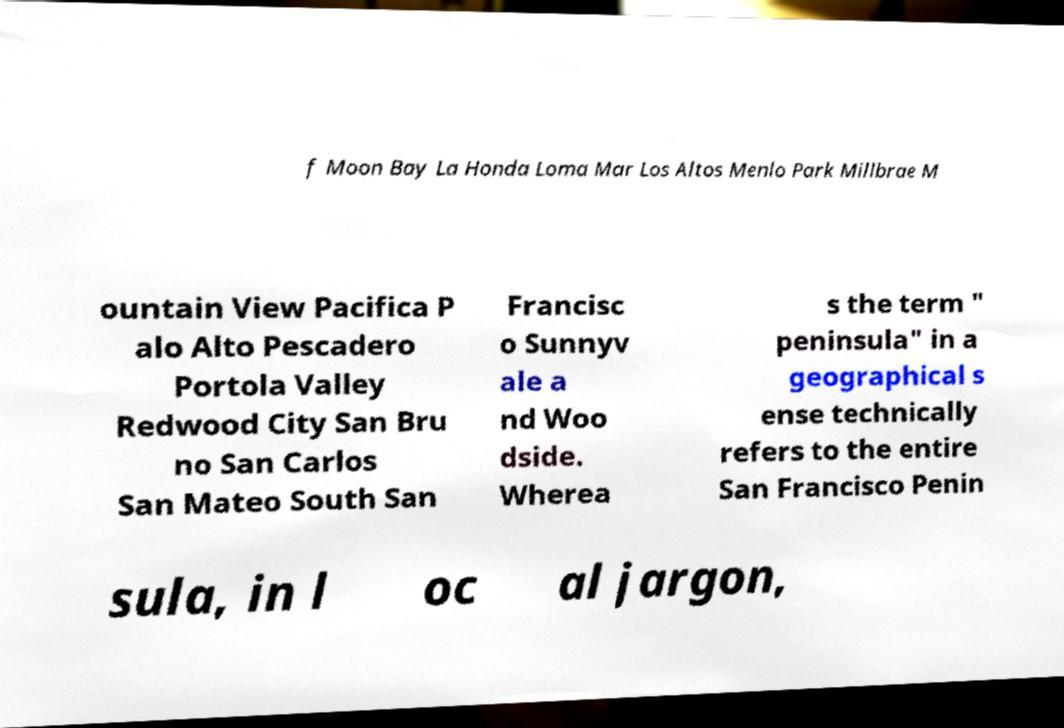There's text embedded in this image that I need extracted. Can you transcribe it verbatim? f Moon Bay La Honda Loma Mar Los Altos Menlo Park Millbrae M ountain View Pacifica P alo Alto Pescadero Portola Valley Redwood City San Bru no San Carlos San Mateo South San Francisc o Sunnyv ale a nd Woo dside. Wherea s the term " peninsula" in a geographical s ense technically refers to the entire San Francisco Penin sula, in l oc al jargon, 